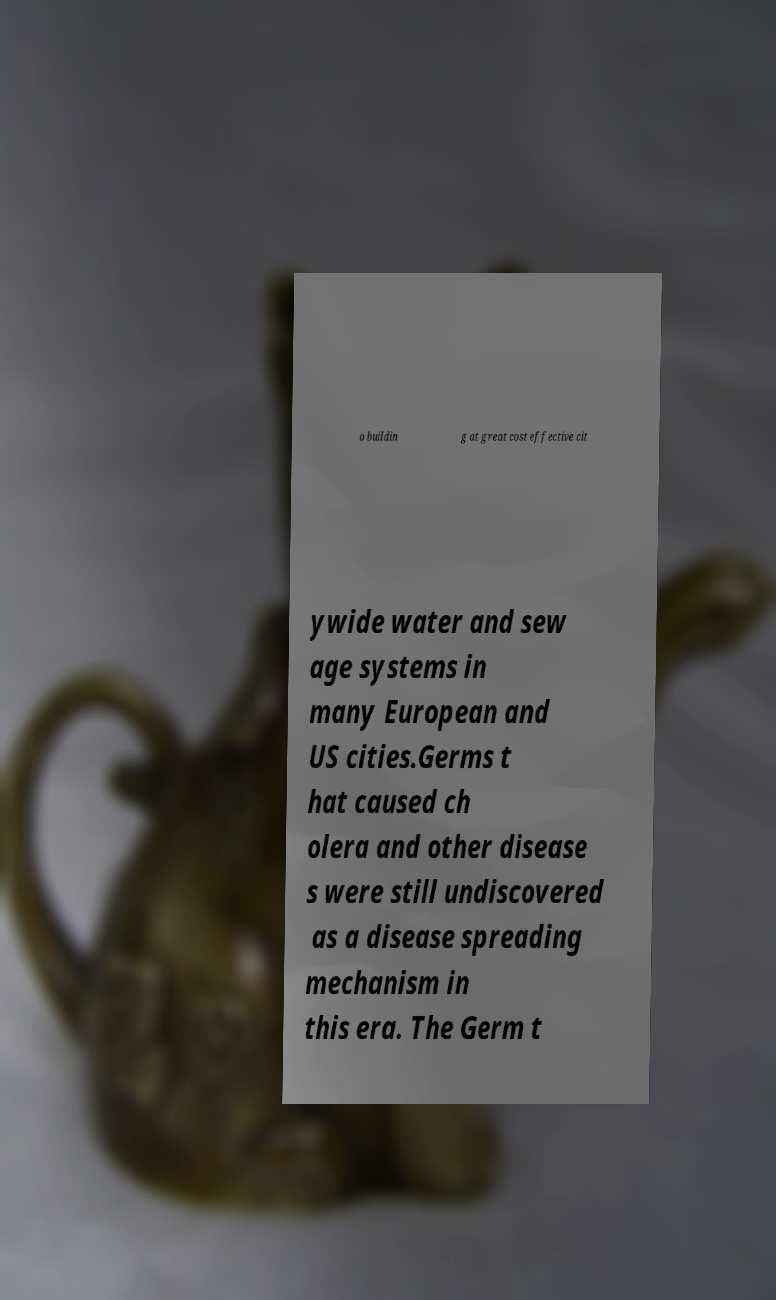What messages or text are displayed in this image? I need them in a readable, typed format. o buildin g at great cost effective cit ywide water and sew age systems in many European and US cities.Germs t hat caused ch olera and other disease s were still undiscovered as a disease spreading mechanism in this era. The Germ t 